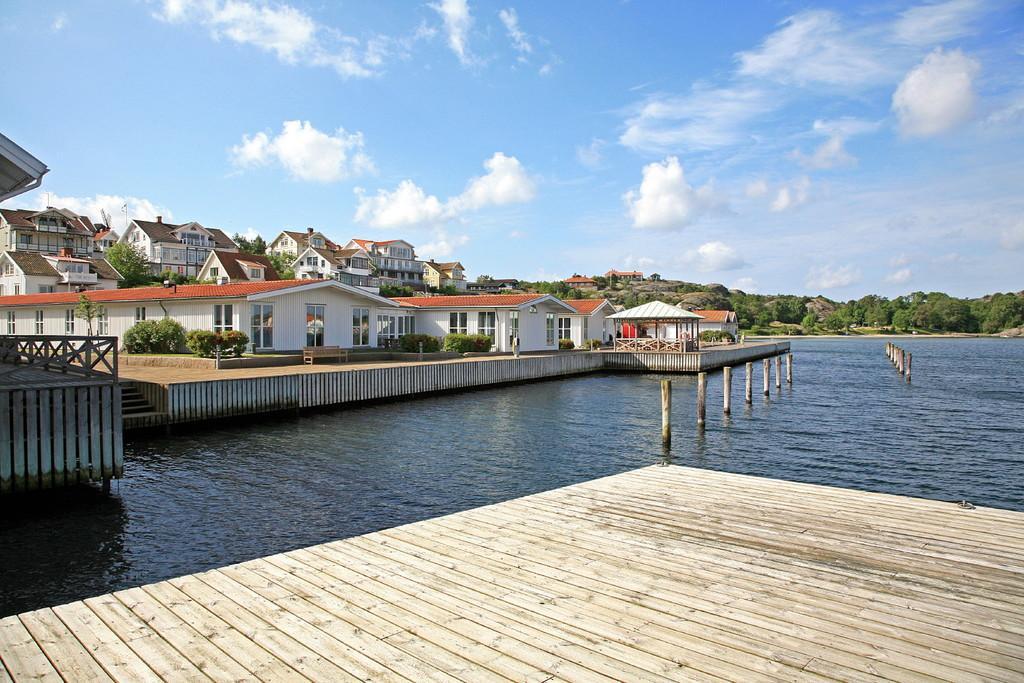Could you give a brief overview of what you see in this image? At the bottom of the image I can see a wooden plank. On the right side, I can see river. In the background there are many buildings and trees. At the top of the image I can see the sky and clouds. 